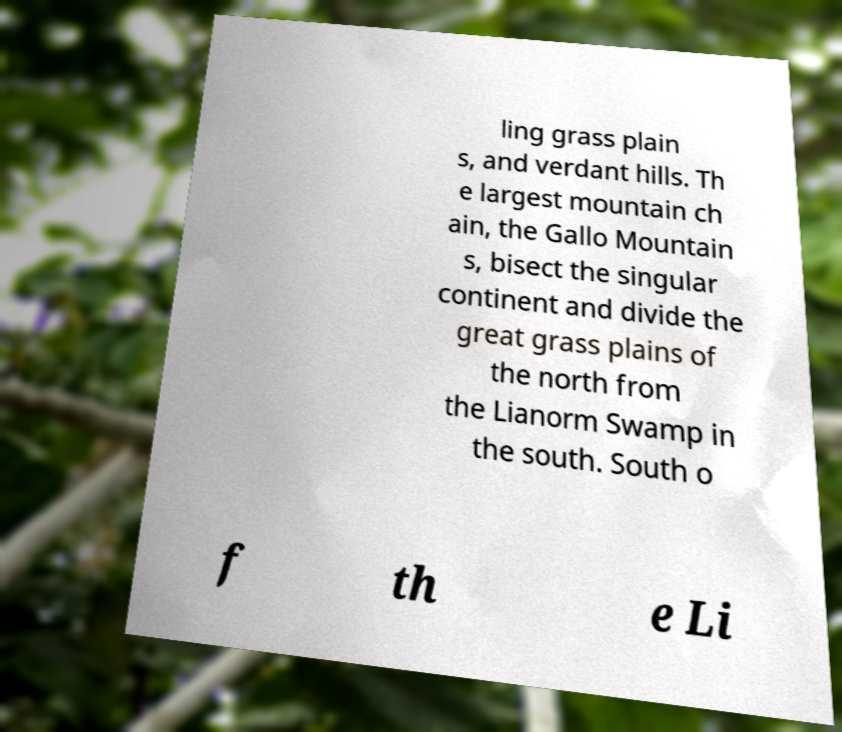There's text embedded in this image that I need extracted. Can you transcribe it verbatim? ling grass plain s, and verdant hills. Th e largest mountain ch ain, the Gallo Mountain s, bisect the singular continent and divide the great grass plains of the north from the Lianorm Swamp in the south. South o f th e Li 